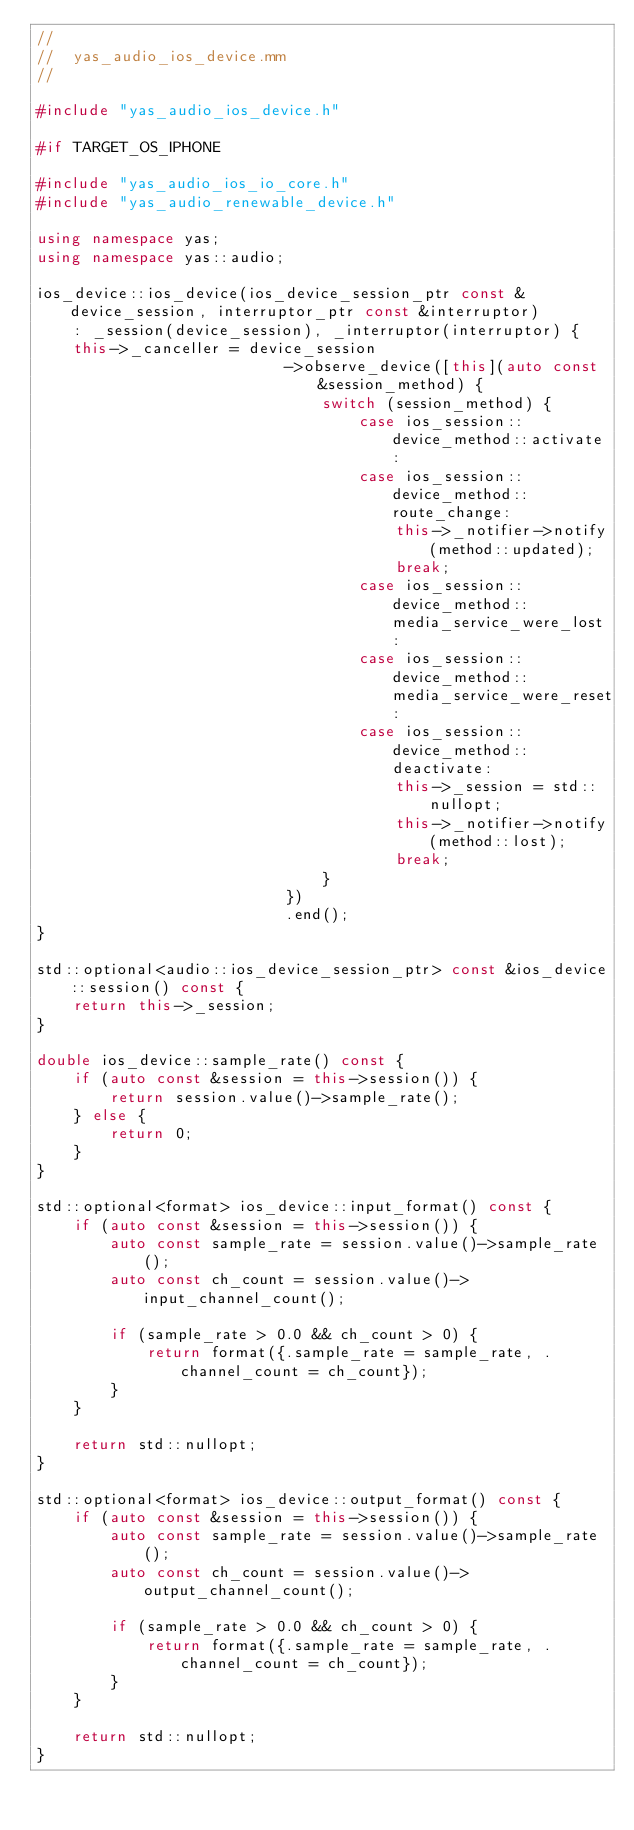<code> <loc_0><loc_0><loc_500><loc_500><_C++_>//
//  yas_audio_ios_device.mm
//

#include "yas_audio_ios_device.h"

#if TARGET_OS_IPHONE

#include "yas_audio_ios_io_core.h"
#include "yas_audio_renewable_device.h"

using namespace yas;
using namespace yas::audio;

ios_device::ios_device(ios_device_session_ptr const &device_session, interruptor_ptr const &interruptor)
    : _session(device_session), _interruptor(interruptor) {
    this->_canceller = device_session
                           ->observe_device([this](auto const &session_method) {
                               switch (session_method) {
                                   case ios_session::device_method::activate:
                                   case ios_session::device_method::route_change:
                                       this->_notifier->notify(method::updated);
                                       break;
                                   case ios_session::device_method::media_service_were_lost:
                                   case ios_session::device_method::media_service_were_reset:
                                   case ios_session::device_method::deactivate:
                                       this->_session = std::nullopt;
                                       this->_notifier->notify(method::lost);
                                       break;
                               }
                           })
                           .end();
}

std::optional<audio::ios_device_session_ptr> const &ios_device::session() const {
    return this->_session;
}

double ios_device::sample_rate() const {
    if (auto const &session = this->session()) {
        return session.value()->sample_rate();
    } else {
        return 0;
    }
}

std::optional<format> ios_device::input_format() const {
    if (auto const &session = this->session()) {
        auto const sample_rate = session.value()->sample_rate();
        auto const ch_count = session.value()->input_channel_count();

        if (sample_rate > 0.0 && ch_count > 0) {
            return format({.sample_rate = sample_rate, .channel_count = ch_count});
        }
    }

    return std::nullopt;
}

std::optional<format> ios_device::output_format() const {
    if (auto const &session = this->session()) {
        auto const sample_rate = session.value()->sample_rate();
        auto const ch_count = session.value()->output_channel_count();

        if (sample_rate > 0.0 && ch_count > 0) {
            return format({.sample_rate = sample_rate, .channel_count = ch_count});
        }
    }

    return std::nullopt;
}
</code> 